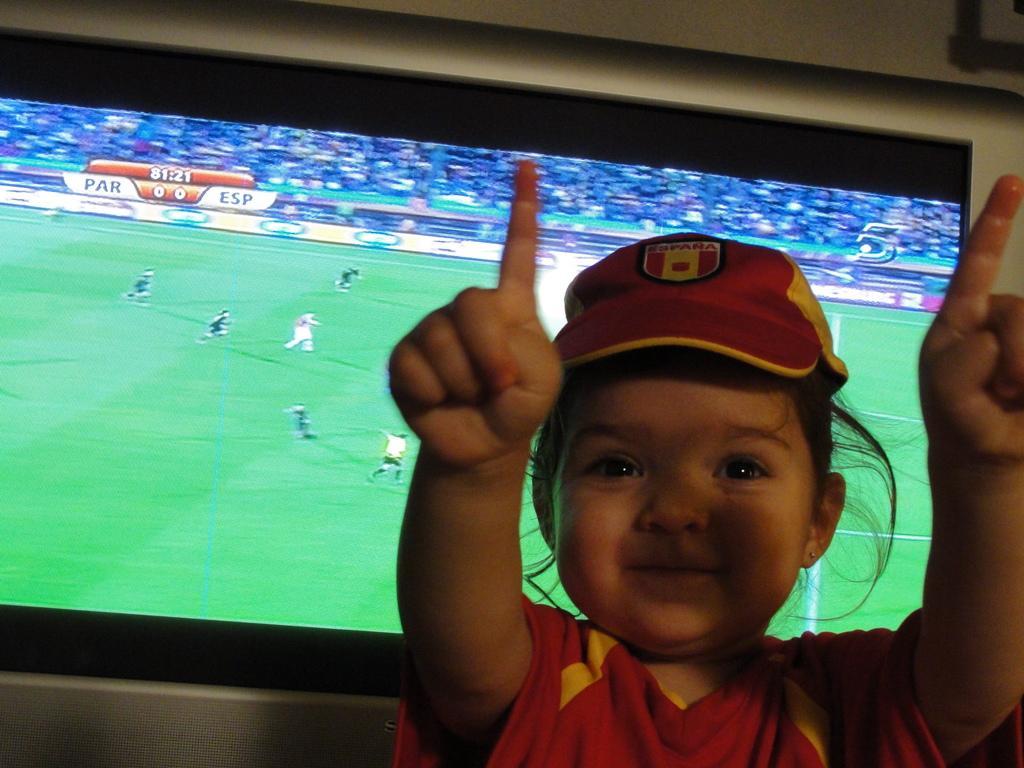Can you describe this image briefly? In this image I can see a child wearing red and yellow colored dress and in the background I can see a huge television screen in which I can see few persons in the ground and few persons sitting in the stadium and the wall. 